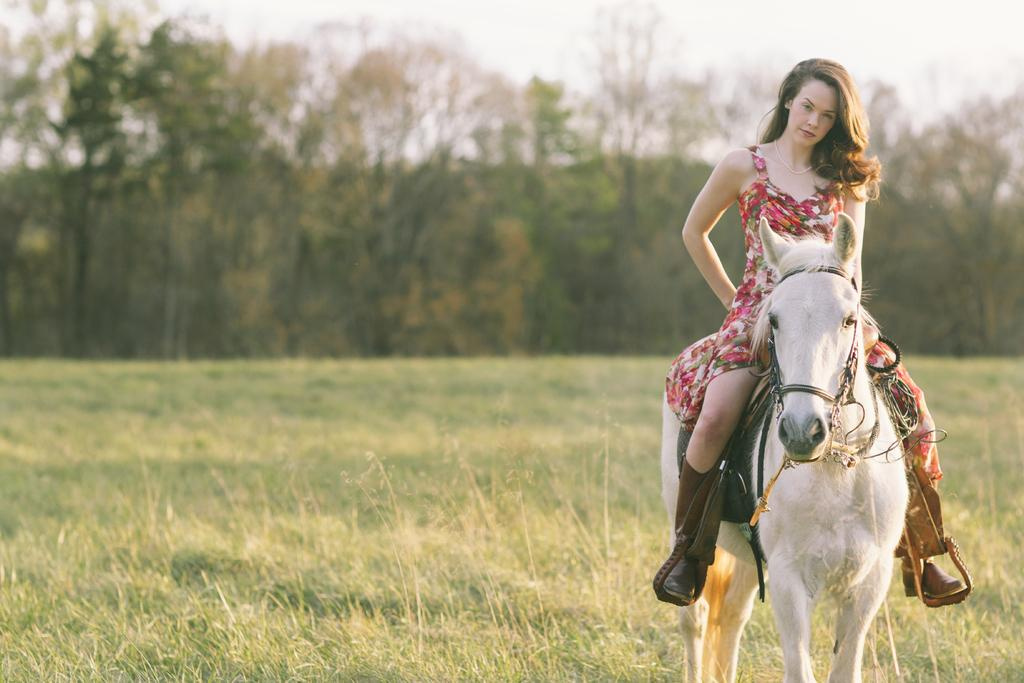Who is the main subject in the image? There is a lady in the image. What is the lady doing in the image? The lady is sitting on a white horse. What can be seen in the background of the image? There are many trees in the background of the image. How does the lady deal with the pollution in the image? There is no mention of pollution in the image, so it cannot be determined how the lady deals with it. 